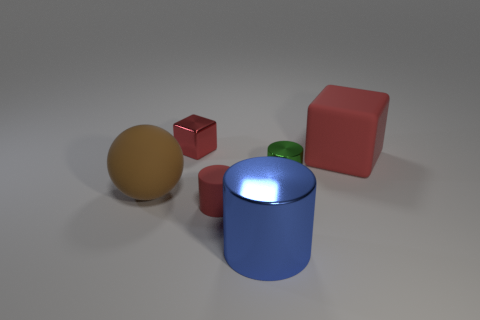Add 3 brown shiny objects. How many objects exist? 9 Subtract all balls. How many objects are left? 5 Subtract all large blue objects. Subtract all large matte things. How many objects are left? 3 Add 1 tiny red things. How many tiny red things are left? 3 Add 4 tiny red matte spheres. How many tiny red matte spheres exist? 4 Subtract 0 green blocks. How many objects are left? 6 